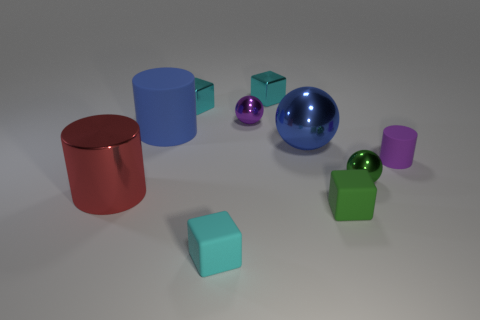Subtract all red cylinders. How many cyan blocks are left? 3 Subtract all blocks. How many objects are left? 6 Subtract 0 brown spheres. How many objects are left? 10 Subtract all blue metallic balls. Subtract all tiny metal objects. How many objects are left? 5 Add 2 cyan cubes. How many cyan cubes are left? 5 Add 4 tiny green matte blocks. How many tiny green matte blocks exist? 5 